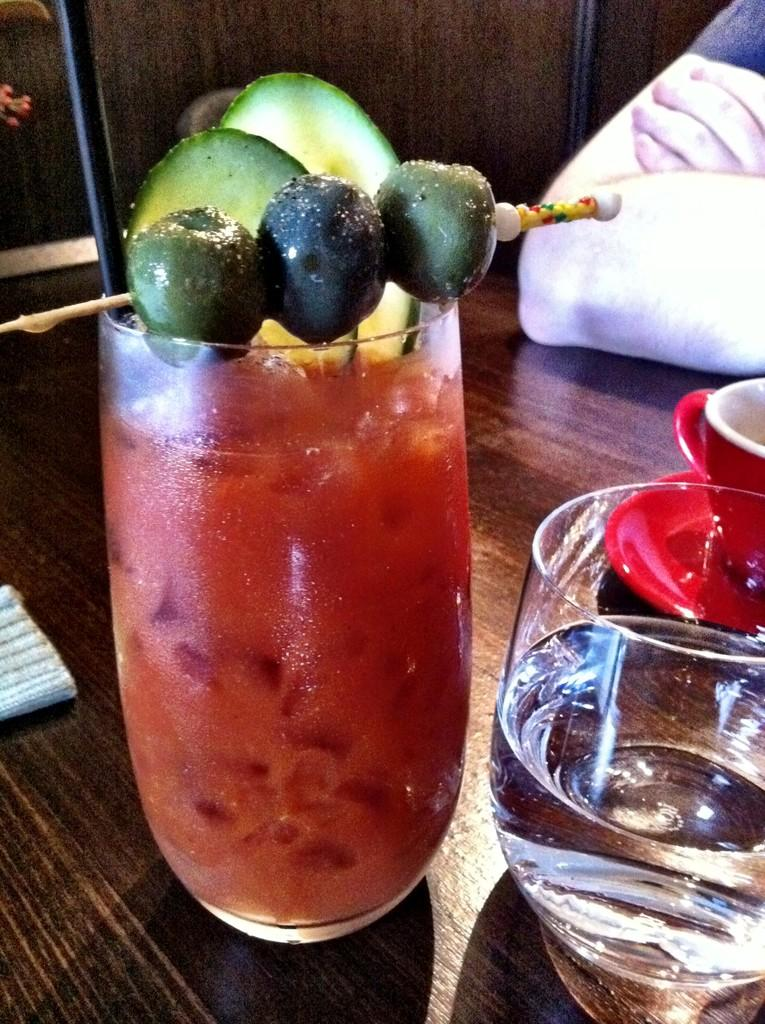What objects are in the image that are used for drinking? There are glasses in the image that are used for drinking. What is inside the glasses? The glasses contain drinks. Where are the glasses located in the image? The glasses are on a table. Can you describe any part of a person visible in the image? There is a person's hand visible in the background of the image. What type of throne is depicted in the image? There is no throne present in the image. Can you describe the facial expression of the person in the image? There is no face visible in the image, only a hand. 